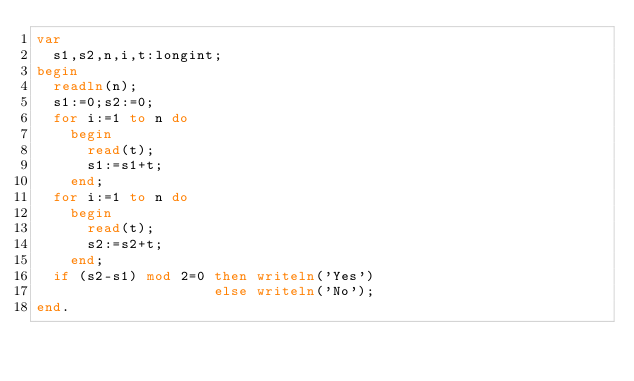<code> <loc_0><loc_0><loc_500><loc_500><_Pascal_>var
  s1,s2,n,i,t:longint;
begin
  readln(n);
  s1:=0;s2:=0;
  for i:=1 to n do
    begin
      read(t);
      s1:=s1+t;
    end;
  for i:=1 to n do
    begin
      read(t);
      s2:=s2+t;
    end;
  if (s2-s1) mod 2=0 then writeln('Yes')
                     else writeln('No');
end.</code> 